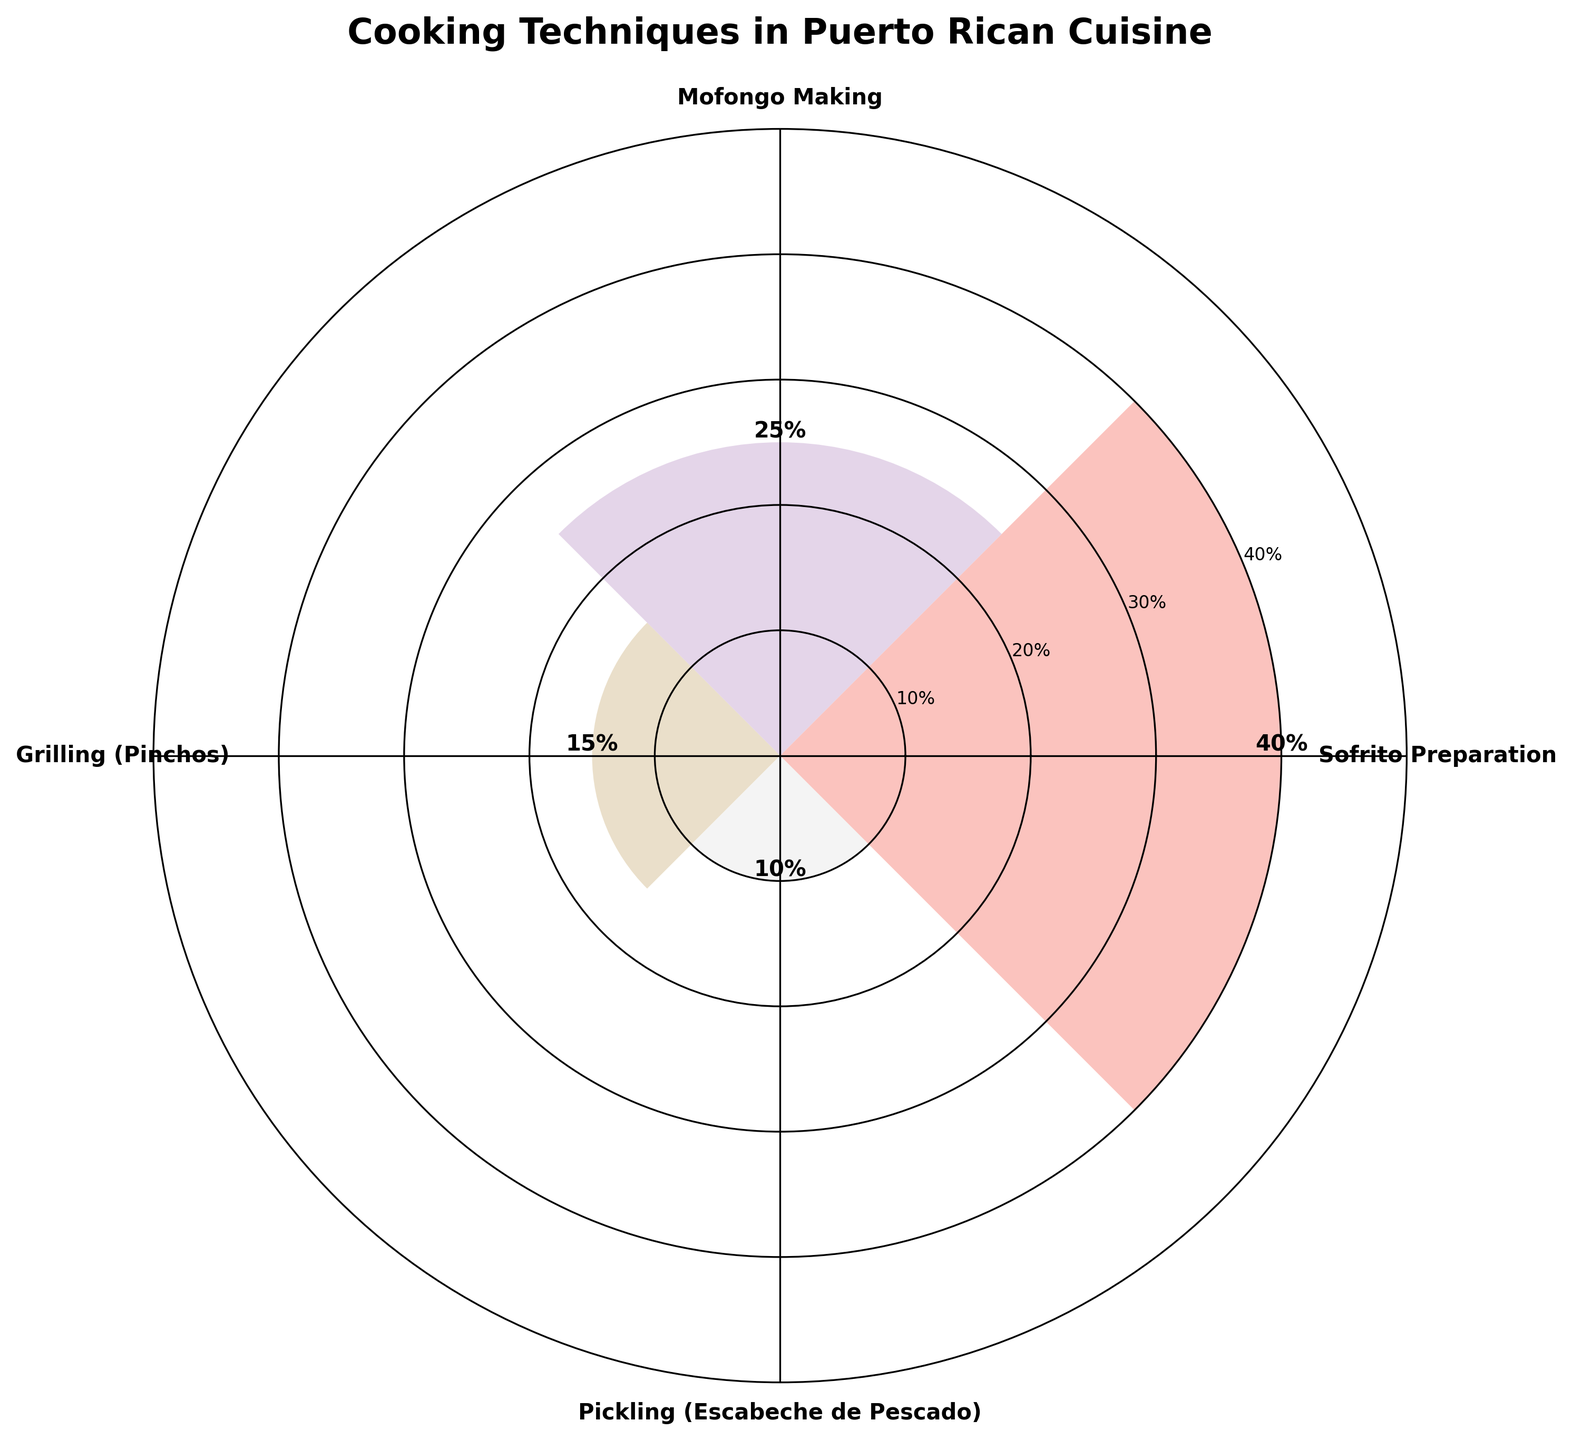What's the title of the chart? The title of the chart is located at the top, styled prominently. It reads "Cooking Techniques in Puerto Rican Cuisine."
Answer: Cooking Techniques in Puerto Rican Cuisine How many cooking techniques are represented in the chart? You can count the number of labels on the outer edge of the polar area chart. There are four different techniques listed.
Answer: Four Which cooking technique has the highest occurrence rate? The tallest bar on the polar area chart represents the technique with the highest occurrence rate. This bar corresponds to "Sofrito Preparation."
Answer: Sofrito Preparation What is the occurrence rate for Mofongo Making? Locate the bar labeled "Mofongo Making" and read the corresponding height labeled directly on the bar. The occurrence rate is 25%.
Answer: 25% What is the difference in occurrence rate between Grilling (Pinchos) and Pickling (Escabeche de Pescado)? To find the difference, subtract the occurrence rate of Pickling (10%) from Grilling (15%): 15% - 10%.
Answer: 5% What percentage of the techniques have an occurrence rate above 20%? There are two techniques with occurrence rates above 20%: Sofrito Preparation (40%) and Mofongo Making (25%). Out of four techniques, this is 2/4, which is 50%.
Answer: 50% Which cooking technique has the smallest occurrence rate? The shortest bar on the polar area chart represents the technique with the smallest occurrence rate. This bar corresponds to "Pickling (Escabeche de Pescado)."
Answer: Pickling (Escabeche de Pescado) Are there any techniques with an occurrence rate below 20%? By examining the chart, we can see that two techniques have occurrence rates below 20%: Grilling (Pinchos) at 15% and Pickling (Escabeche de Pescado) at 10%.
Answer: Yes What's the total occurrence rate combined for all techniques? Add up all the occurrence rates shown on the bars: 40% + 25% + 15% + 10% = 90%.
Answer: 90% What color palettes are used in the chart? The wedges are shaded in various pastel colors as seen in the polar area chart. The exact names of the colors used are mainly in pastel shades.
Answer: Pastel 